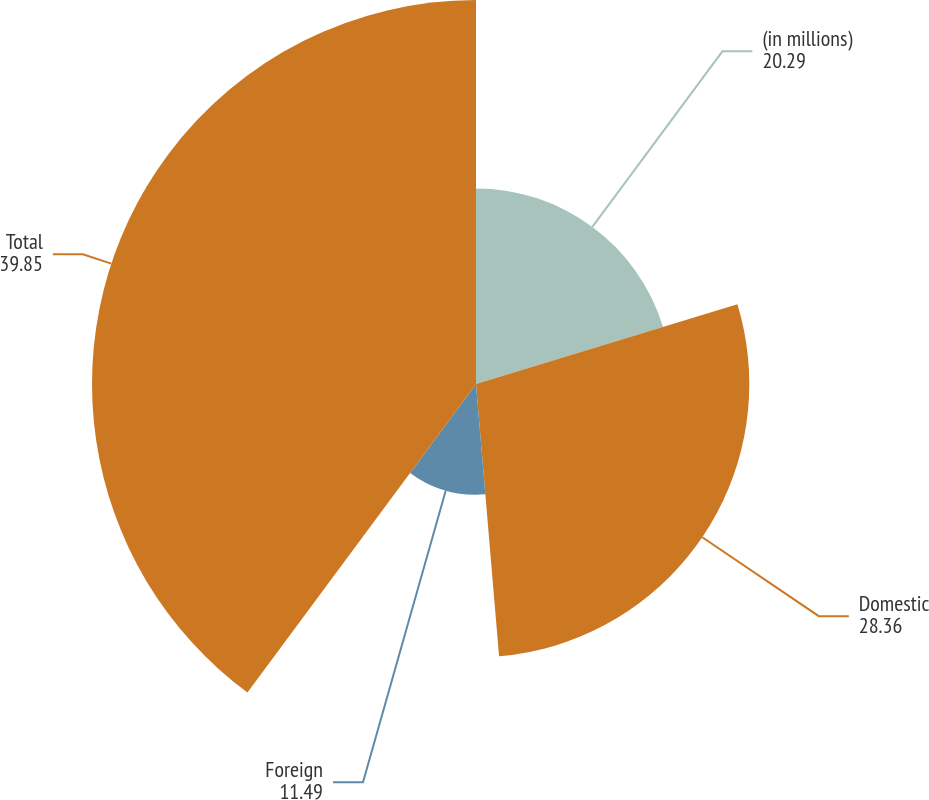Convert chart to OTSL. <chart><loc_0><loc_0><loc_500><loc_500><pie_chart><fcel>(in millions)<fcel>Domestic<fcel>Foreign<fcel>Total<nl><fcel>20.29%<fcel>28.36%<fcel>11.49%<fcel>39.85%<nl></chart> 